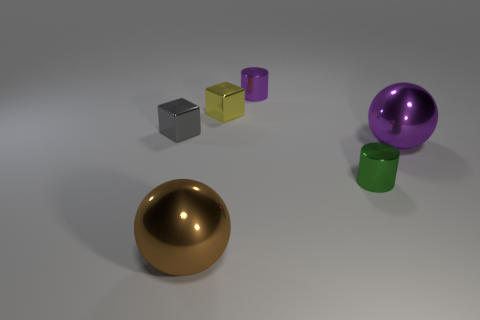Add 2 tiny green cylinders. How many objects exist? 8 Subtract all blocks. How many objects are left? 4 Subtract 0 green balls. How many objects are left? 6 Subtract all small green blocks. Subtract all green cylinders. How many objects are left? 5 Add 6 large purple shiny objects. How many large purple shiny objects are left? 7 Add 1 cylinders. How many cylinders exist? 3 